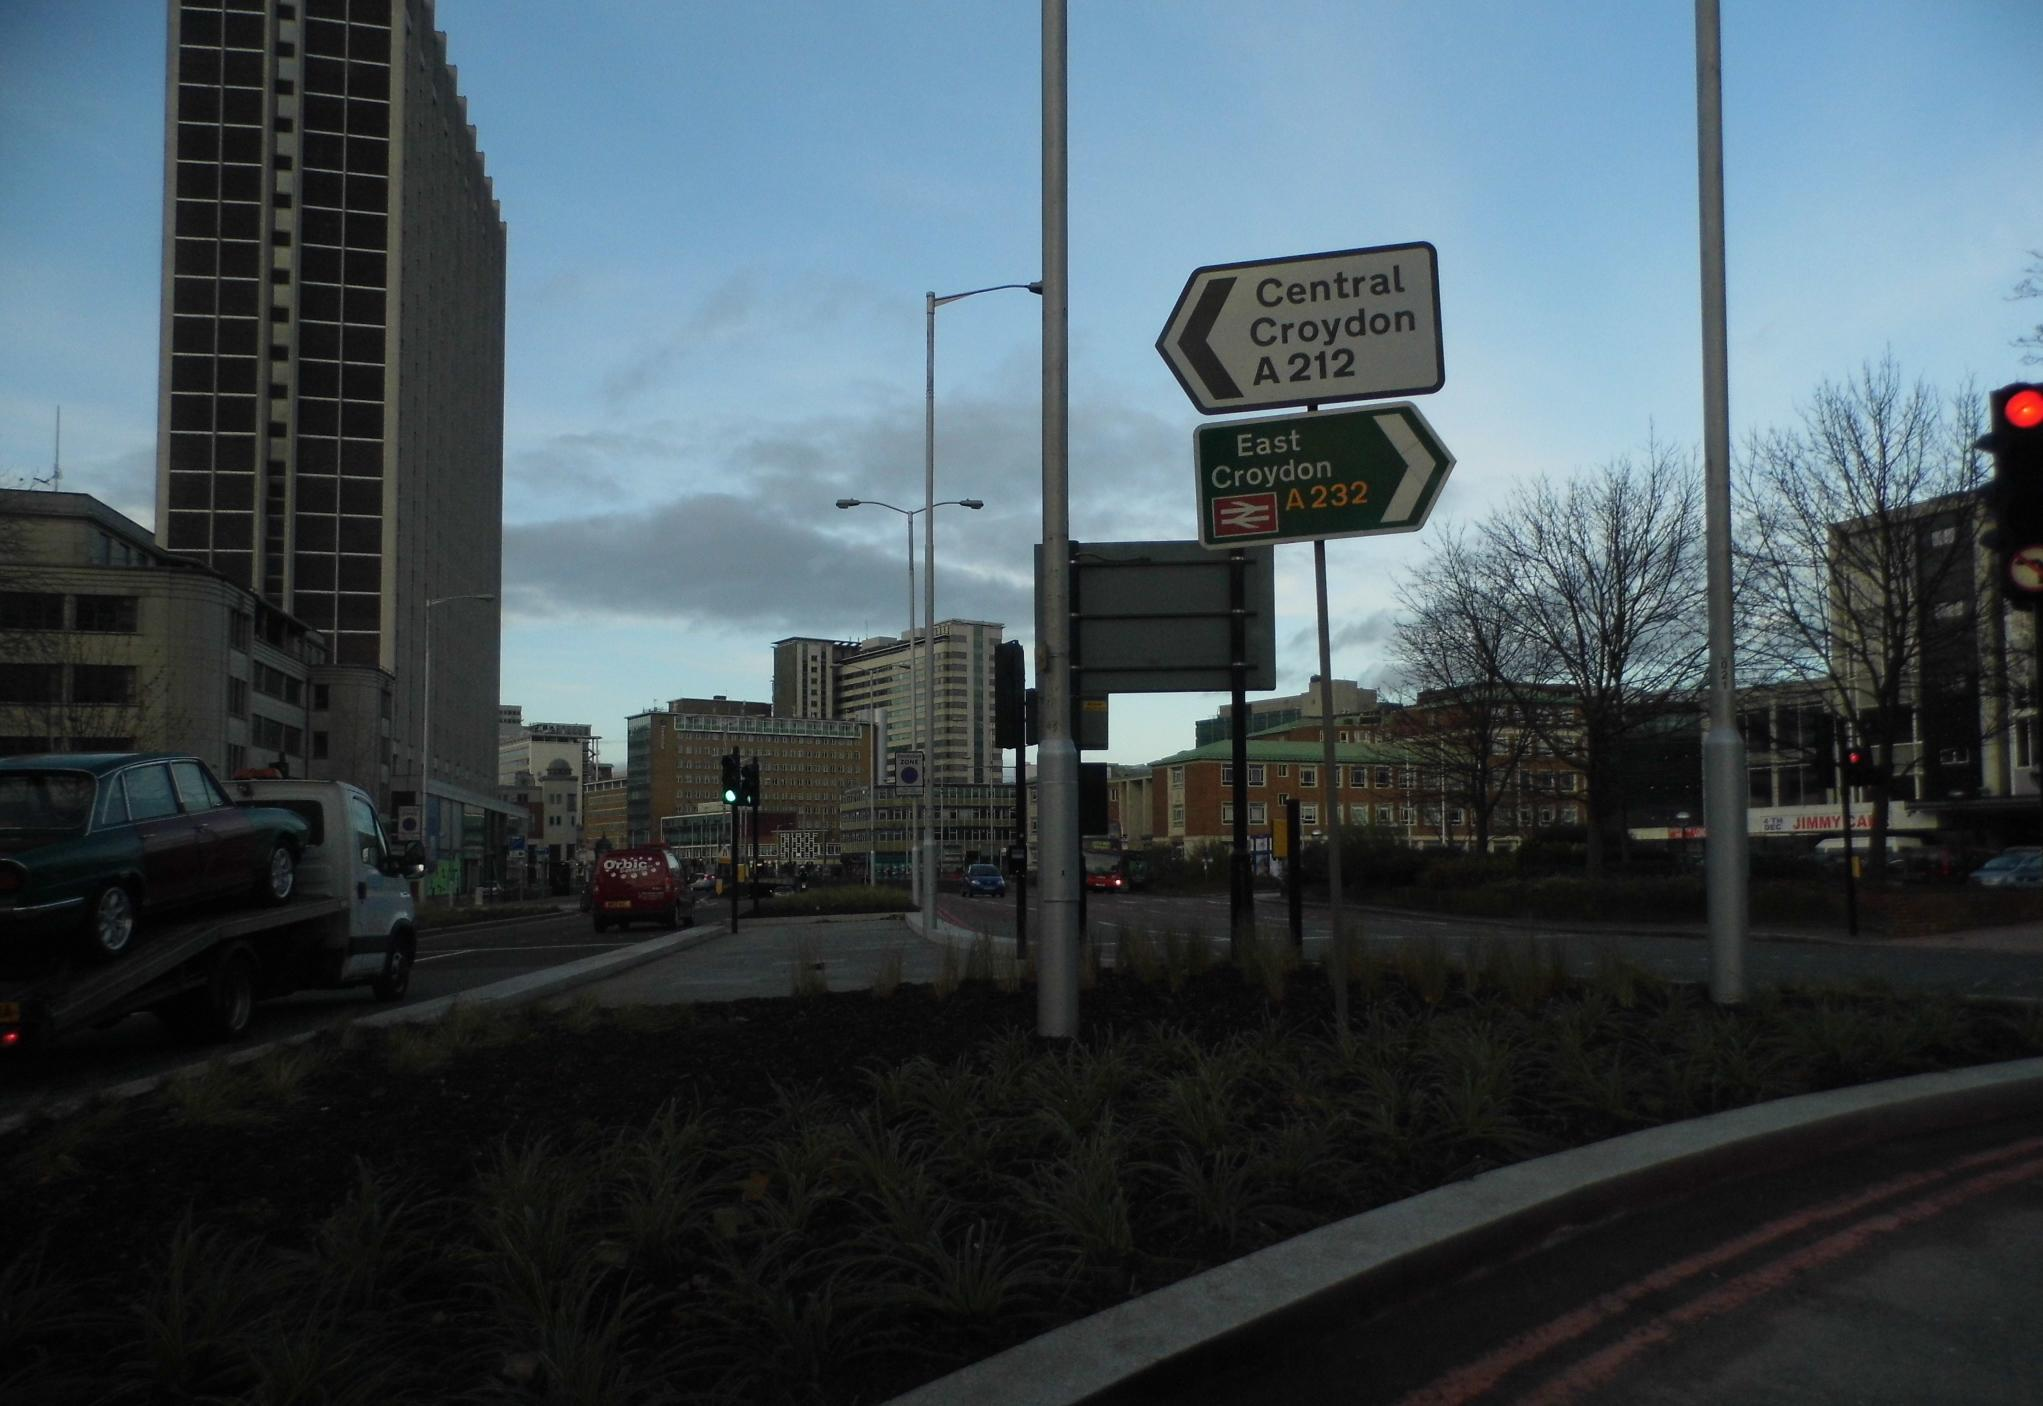What is the main feature of the image? There is a road at the center of the image. What else can be seen in the image besides the road? There are buildings, trees, vehicles, utility poles, and the sky visible in the image. What type of structures are present in the image? The buildings in the image are likely residential or commercial structures. How are the vehicles positioned in the image? Vehicles are passing on the road in the image. What is the price of the stone drink being sold in the image? There is no stone drink or any indication of a price in the image. 